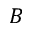<formula> <loc_0><loc_0><loc_500><loc_500>B</formula> 